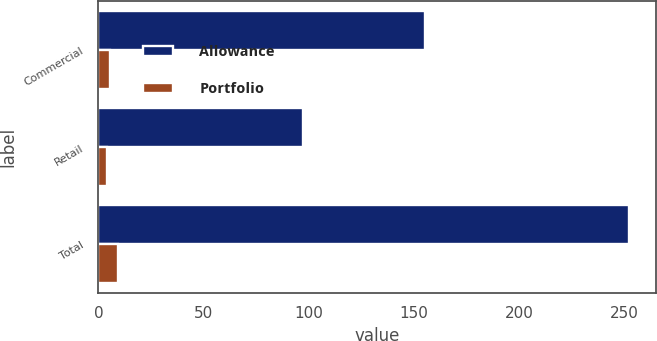Convert chart to OTSL. <chart><loc_0><loc_0><loc_500><loc_500><stacked_bar_chart><ecel><fcel>Commercial<fcel>Retail<fcel>Total<nl><fcel>Allowance<fcel>155.1<fcel>97<fcel>252.1<nl><fcel>Portfolio<fcel>5.5<fcel>3.9<fcel>9.4<nl></chart> 